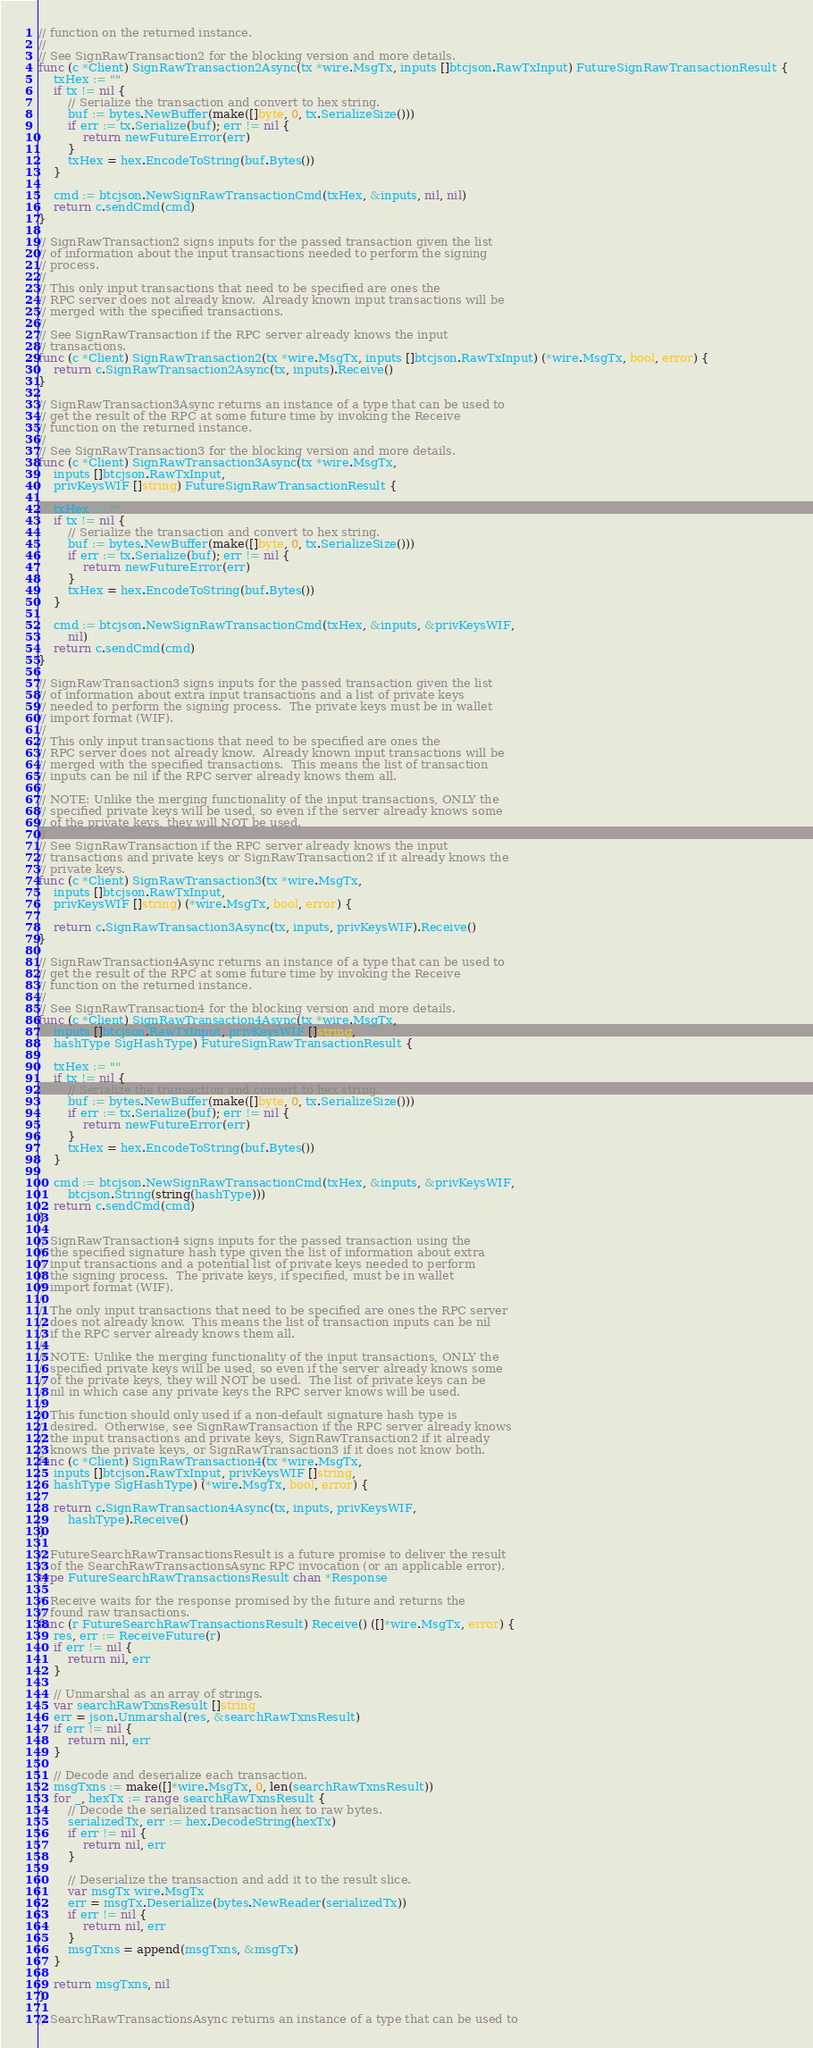Convert code to text. <code><loc_0><loc_0><loc_500><loc_500><_Go_>// function on the returned instance.
//
// See SignRawTransaction2 for the blocking version and more details.
func (c *Client) SignRawTransaction2Async(tx *wire.MsgTx, inputs []btcjson.RawTxInput) FutureSignRawTransactionResult {
	txHex := ""
	if tx != nil {
		// Serialize the transaction and convert to hex string.
		buf := bytes.NewBuffer(make([]byte, 0, tx.SerializeSize()))
		if err := tx.Serialize(buf); err != nil {
			return newFutureError(err)
		}
		txHex = hex.EncodeToString(buf.Bytes())
	}

	cmd := btcjson.NewSignRawTransactionCmd(txHex, &inputs, nil, nil)
	return c.sendCmd(cmd)
}

// SignRawTransaction2 signs inputs for the passed transaction given the list
// of information about the input transactions needed to perform the signing
// process.
//
// This only input transactions that need to be specified are ones the
// RPC server does not already know.  Already known input transactions will be
// merged with the specified transactions.
//
// See SignRawTransaction if the RPC server already knows the input
// transactions.
func (c *Client) SignRawTransaction2(tx *wire.MsgTx, inputs []btcjson.RawTxInput) (*wire.MsgTx, bool, error) {
	return c.SignRawTransaction2Async(tx, inputs).Receive()
}

// SignRawTransaction3Async returns an instance of a type that can be used to
// get the result of the RPC at some future time by invoking the Receive
// function on the returned instance.
//
// See SignRawTransaction3 for the blocking version and more details.
func (c *Client) SignRawTransaction3Async(tx *wire.MsgTx,
	inputs []btcjson.RawTxInput,
	privKeysWIF []string) FutureSignRawTransactionResult {

	txHex := ""
	if tx != nil {
		// Serialize the transaction and convert to hex string.
		buf := bytes.NewBuffer(make([]byte, 0, tx.SerializeSize()))
		if err := tx.Serialize(buf); err != nil {
			return newFutureError(err)
		}
		txHex = hex.EncodeToString(buf.Bytes())
	}

	cmd := btcjson.NewSignRawTransactionCmd(txHex, &inputs, &privKeysWIF,
		nil)
	return c.sendCmd(cmd)
}

// SignRawTransaction3 signs inputs for the passed transaction given the list
// of information about extra input transactions and a list of private keys
// needed to perform the signing process.  The private keys must be in wallet
// import format (WIF).
//
// This only input transactions that need to be specified are ones the
// RPC server does not already know.  Already known input transactions will be
// merged with the specified transactions.  This means the list of transaction
// inputs can be nil if the RPC server already knows them all.
//
// NOTE: Unlike the merging functionality of the input transactions, ONLY the
// specified private keys will be used, so even if the server already knows some
// of the private keys, they will NOT be used.
//
// See SignRawTransaction if the RPC server already knows the input
// transactions and private keys or SignRawTransaction2 if it already knows the
// private keys.
func (c *Client) SignRawTransaction3(tx *wire.MsgTx,
	inputs []btcjson.RawTxInput,
	privKeysWIF []string) (*wire.MsgTx, bool, error) {

	return c.SignRawTransaction3Async(tx, inputs, privKeysWIF).Receive()
}

// SignRawTransaction4Async returns an instance of a type that can be used to
// get the result of the RPC at some future time by invoking the Receive
// function on the returned instance.
//
// See SignRawTransaction4 for the blocking version and more details.
func (c *Client) SignRawTransaction4Async(tx *wire.MsgTx,
	inputs []btcjson.RawTxInput, privKeysWIF []string,
	hashType SigHashType) FutureSignRawTransactionResult {

	txHex := ""
	if tx != nil {
		// Serialize the transaction and convert to hex string.
		buf := bytes.NewBuffer(make([]byte, 0, tx.SerializeSize()))
		if err := tx.Serialize(buf); err != nil {
			return newFutureError(err)
		}
		txHex = hex.EncodeToString(buf.Bytes())
	}

	cmd := btcjson.NewSignRawTransactionCmd(txHex, &inputs, &privKeysWIF,
		btcjson.String(string(hashType)))
	return c.sendCmd(cmd)
}

// SignRawTransaction4 signs inputs for the passed transaction using the
// the specified signature hash type given the list of information about extra
// input transactions and a potential list of private keys needed to perform
// the signing process.  The private keys, if specified, must be in wallet
// import format (WIF).
//
// The only input transactions that need to be specified are ones the RPC server
// does not already know.  This means the list of transaction inputs can be nil
// if the RPC server already knows them all.
//
// NOTE: Unlike the merging functionality of the input transactions, ONLY the
// specified private keys will be used, so even if the server already knows some
// of the private keys, they will NOT be used.  The list of private keys can be
// nil in which case any private keys the RPC server knows will be used.
//
// This function should only used if a non-default signature hash type is
// desired.  Otherwise, see SignRawTransaction if the RPC server already knows
// the input transactions and private keys, SignRawTransaction2 if it already
// knows the private keys, or SignRawTransaction3 if it does not know both.
func (c *Client) SignRawTransaction4(tx *wire.MsgTx,
	inputs []btcjson.RawTxInput, privKeysWIF []string,
	hashType SigHashType) (*wire.MsgTx, bool, error) {

	return c.SignRawTransaction4Async(tx, inputs, privKeysWIF,
		hashType).Receive()
}

// FutureSearchRawTransactionsResult is a future promise to deliver the result
// of the SearchRawTransactionsAsync RPC invocation (or an applicable error).
type FutureSearchRawTransactionsResult chan *Response

// Receive waits for the response promised by the future and returns the
// found raw transactions.
func (r FutureSearchRawTransactionsResult) Receive() ([]*wire.MsgTx, error) {
	res, err := ReceiveFuture(r)
	if err != nil {
		return nil, err
	}

	// Unmarshal as an array of strings.
	var searchRawTxnsResult []string
	err = json.Unmarshal(res, &searchRawTxnsResult)
	if err != nil {
		return nil, err
	}

	// Decode and deserialize each transaction.
	msgTxns := make([]*wire.MsgTx, 0, len(searchRawTxnsResult))
	for _, hexTx := range searchRawTxnsResult {
		// Decode the serialized transaction hex to raw bytes.
		serializedTx, err := hex.DecodeString(hexTx)
		if err != nil {
			return nil, err
		}

		// Deserialize the transaction and add it to the result slice.
		var msgTx wire.MsgTx
		err = msgTx.Deserialize(bytes.NewReader(serializedTx))
		if err != nil {
			return nil, err
		}
		msgTxns = append(msgTxns, &msgTx)
	}

	return msgTxns, nil
}

// SearchRawTransactionsAsync returns an instance of a type that can be used to</code> 